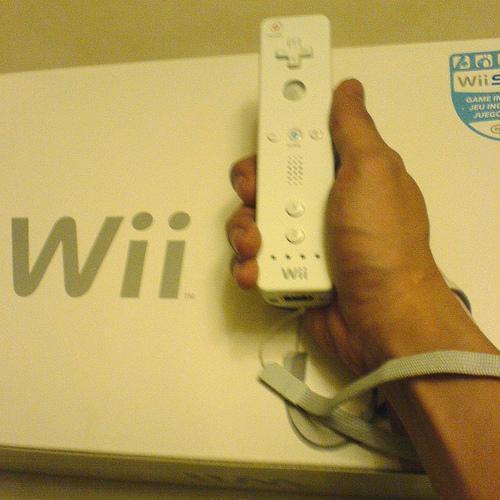How many remotes can you see?
Give a very brief answer. 1. 